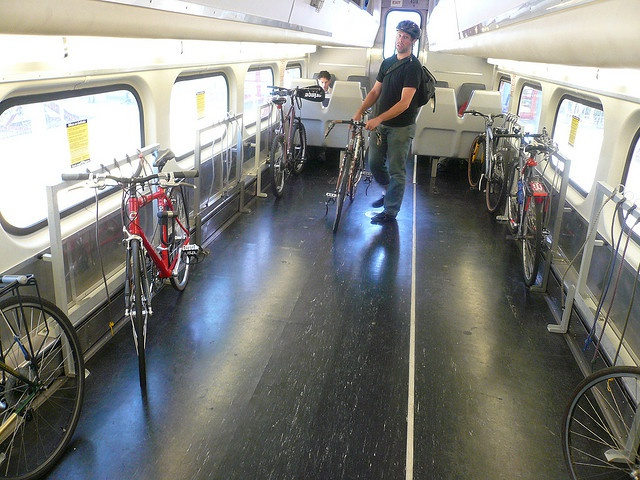Describe the objects in this image and their specific colors. I can see train in tan, white, gray, beige, and darkgray tones, bicycle in tan, black, gray, and darkgreen tones, bicycle in tan, gray, black, darkgray, and white tones, bicycle in tan, black, gray, darkgreen, and darkgray tones, and people in tan, black, gray, blue, and navy tones in this image. 